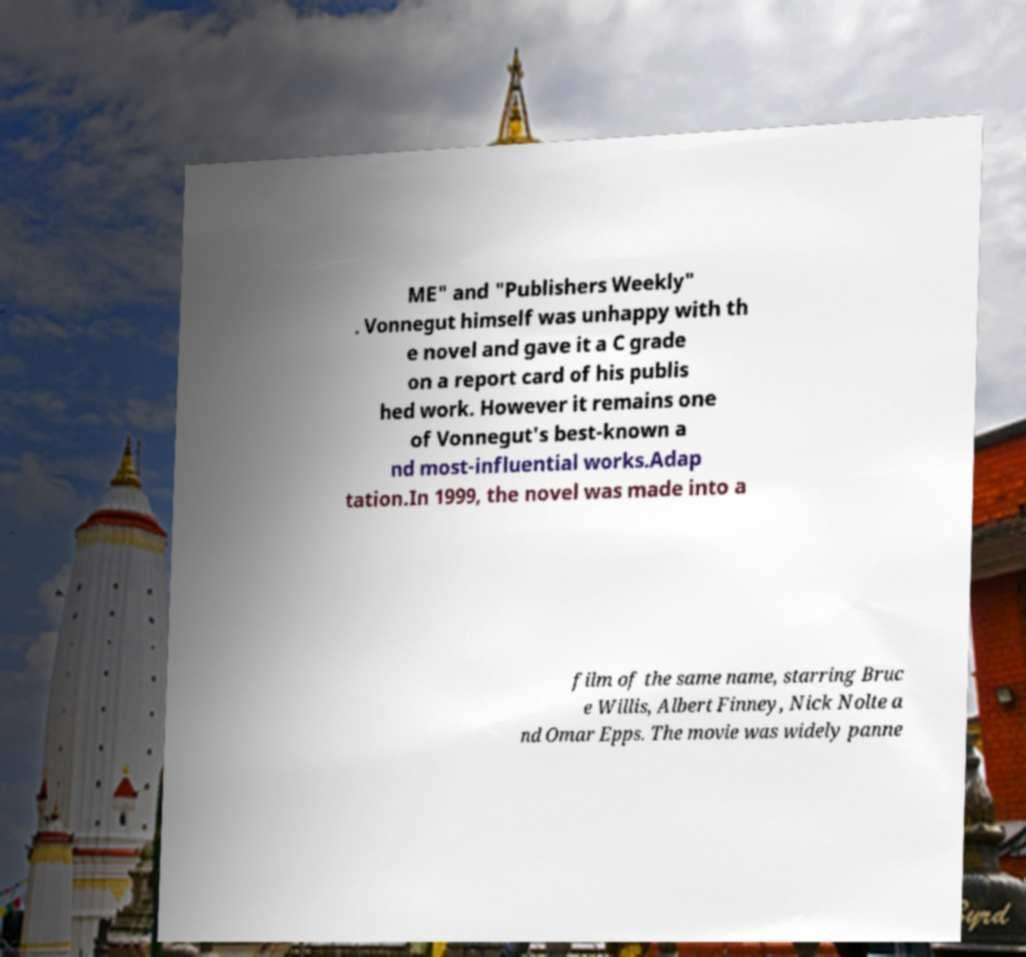For documentation purposes, I need the text within this image transcribed. Could you provide that? ME" and "Publishers Weekly" . Vonnegut himself was unhappy with th e novel and gave it a C grade on a report card of his publis hed work. However it remains one of Vonnegut's best-known a nd most-influential works.Adap tation.In 1999, the novel was made into a film of the same name, starring Bruc e Willis, Albert Finney, Nick Nolte a nd Omar Epps. The movie was widely panne 